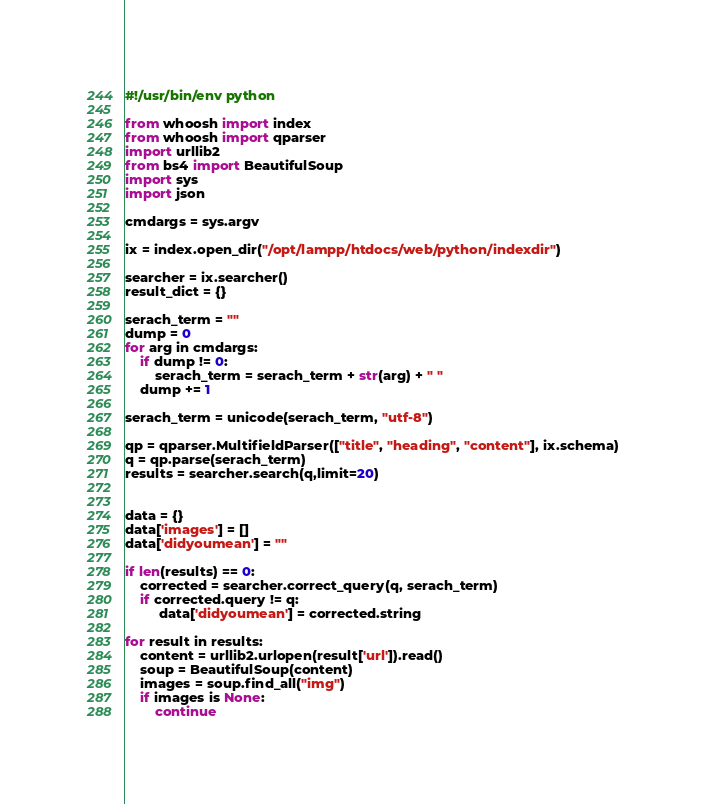Convert code to text. <code><loc_0><loc_0><loc_500><loc_500><_Python_>#!/usr/bin/env python

from whoosh import index
from whoosh import qparser 
import urllib2
from bs4 import BeautifulSoup
import sys
import json

cmdargs = sys.argv

ix = index.open_dir("/opt/lampp/htdocs/web/python/indexdir")

searcher = ix.searcher()
result_dict = {}

serach_term = ""
dump = 0
for arg in cmdargs:
	if dump != 0:
		serach_term = serach_term + str(arg) + " "
	dump += 1

serach_term = unicode(serach_term, "utf-8")

qp = qparser.MultifieldParser(["title", "heading", "content"], ix.schema)
q = qp.parse(serach_term) 	
results = searcher.search(q,limit=20)


data = {}
data['images'] = []
data['didyoumean'] = ""

if len(results) == 0:
	corrected = searcher.correct_query(q, serach_term)
	if corrected.query != q:
	     data['didyoumean'] = corrected.string

for result in results:
	content = urllib2.urlopen(result['url']).read()
	soup = BeautifulSoup(content)
	images = soup.find_all("img")
	if images is None:
		continue</code> 